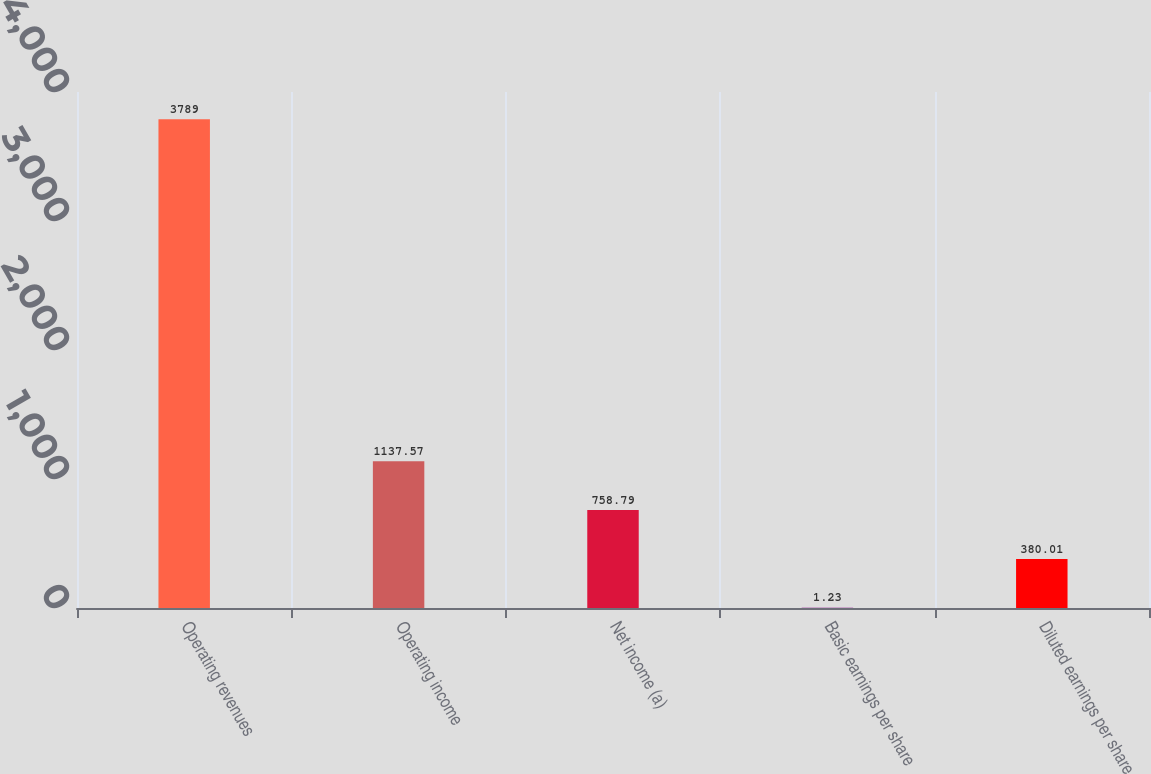<chart> <loc_0><loc_0><loc_500><loc_500><bar_chart><fcel>Operating revenues<fcel>Operating income<fcel>Net income (a)<fcel>Basic earnings per share<fcel>Diluted earnings per share<nl><fcel>3789<fcel>1137.57<fcel>758.79<fcel>1.23<fcel>380.01<nl></chart> 